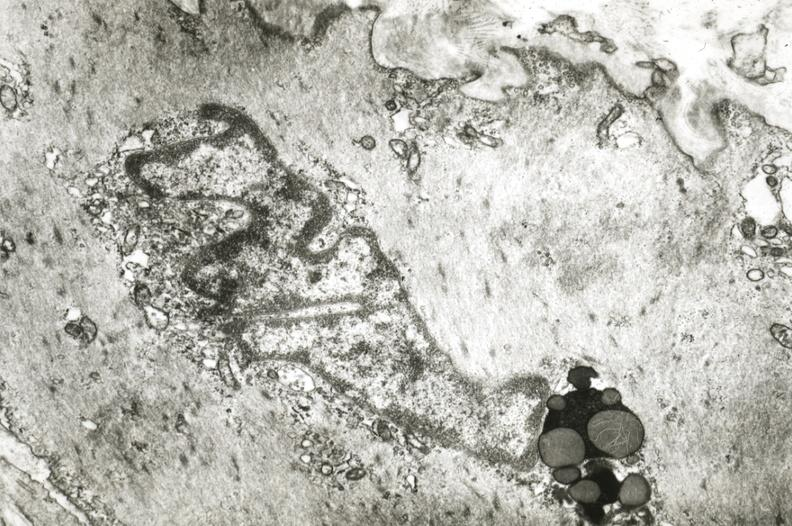s cardiovascular present?
Answer the question using a single word or phrase. Yes 